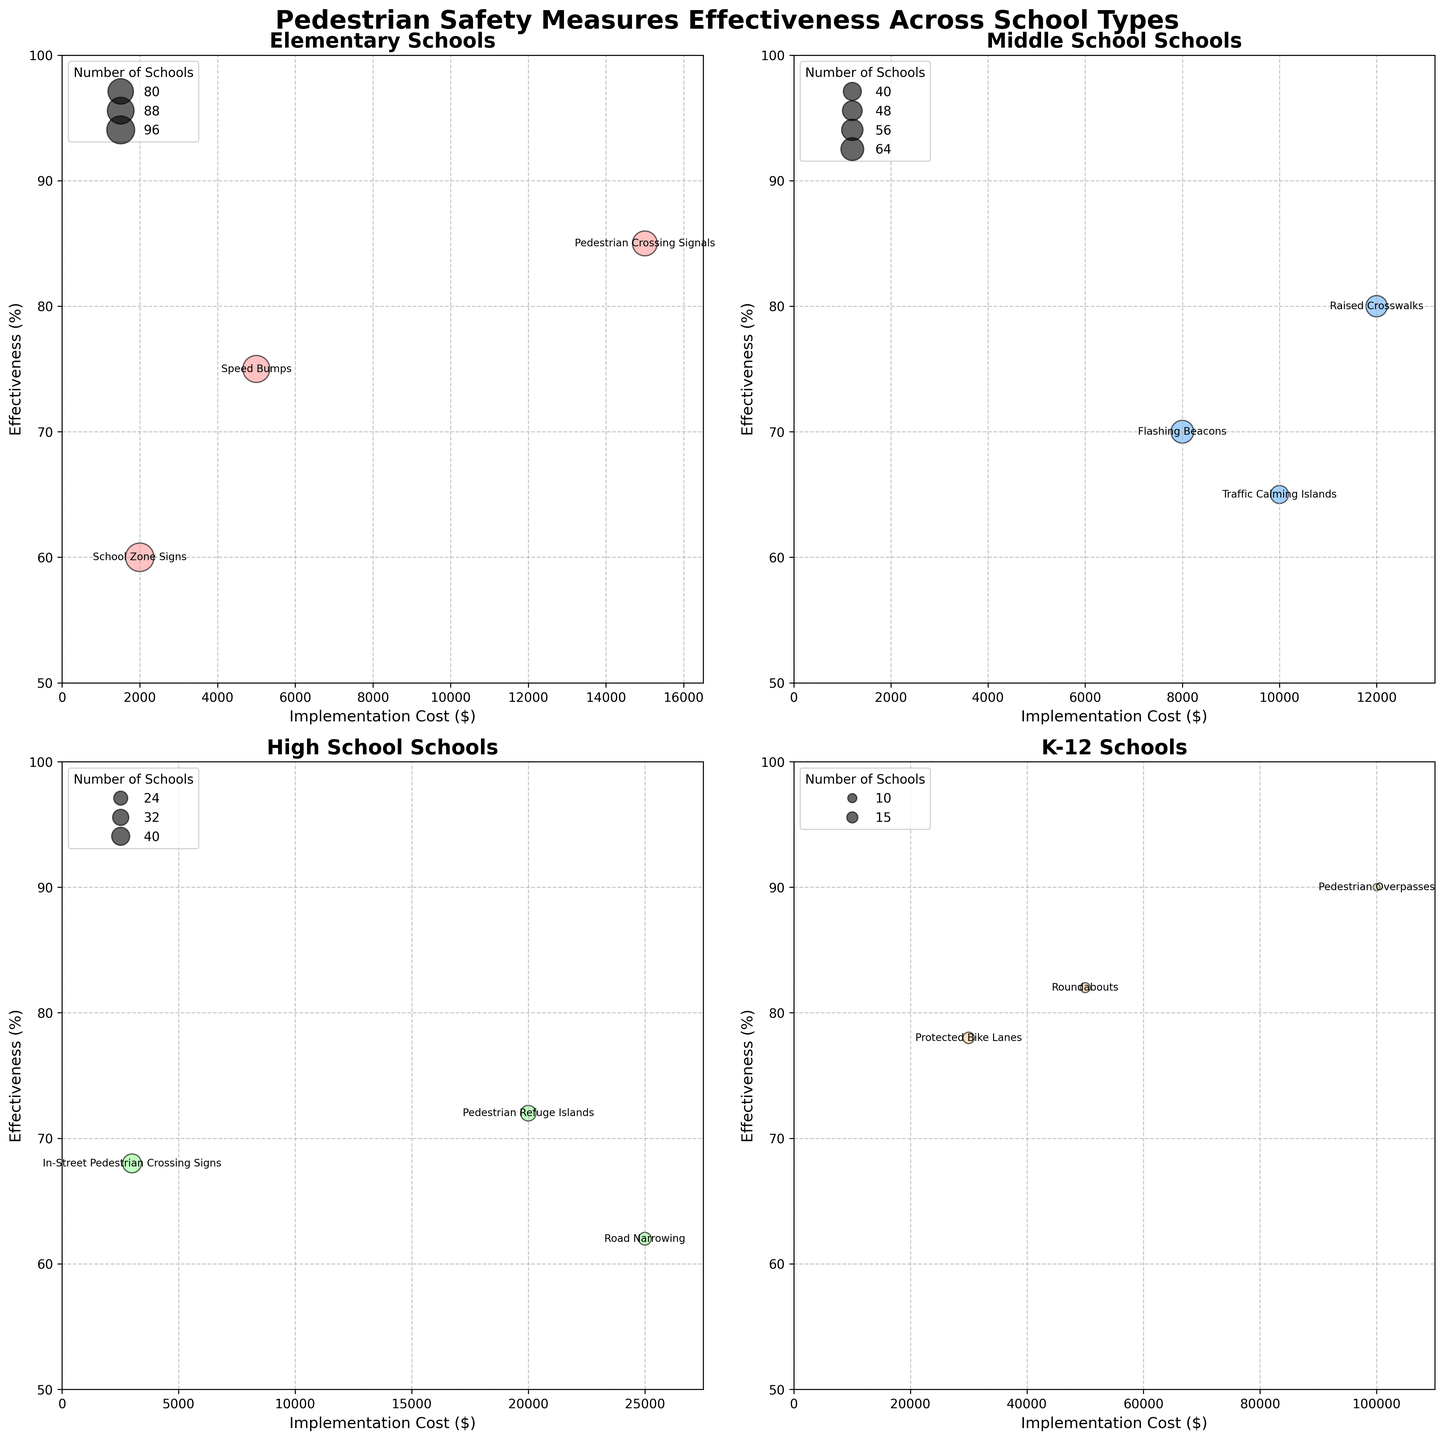What is the title of the plot? The title of the plot is displayed at the top center of the figure. It reads "Pedestrian Safety Measures Effectiveness Across School Types".
Answer: Pedestrian Safety Measures Effectiveness Across School Types How many safety measures are shown for Elementary schools? By observing the subplot dedicated to Elementary schools, we can count the number of annotated safety measures. There are three measures listed: Speed Bumps, Pedestrian Crossing Signals, and School Zone Signs.
Answer: 3 Which school type has a safety measure with the highest effectiveness percentage? By looking at the y-axis representing effectiveness in all subplots, we see that Pedestrian Overpasses in the K-12 subplot reaches the highest effectiveness at 90%. No other measures surpass this percentage.
Answer: K-12 What is the average implementation cost of the safety measures for Middle School? The safety measures for Middle School have implementation costs of $12,000, $8,000, and $10,000. Summing these gives $30,000, and dividing by the 3 measures gives an average cost of $10,000.
Answer: $10,000 Which safety measure for High School has the lowest effectiveness percentage and what is its implementation cost? In the subplot for High School, by comparing effectiveness percentages, Road Narrowing is identified with the lowest at 62%. Its implementation cost is $25,000.
Answer: Road Narrowing, $25,000 What is the total number of schools that have implemented Raised Crosswalks and Flashing Beacons in Middle Schools? Refer to the Middle School subplot and look at the annotations. Raised Crosswalks have 280 schools and Flashing Beacons have 320 schools. Summing these gives a total of 600 schools.
Answer: 600 Which safety measure across all school types has the largest bubble size, indicating the highest number of schools implemented? By examining the varying bubble sizes, School Zone Signs in Elementary schools have the largest bubble, indicating 500 schools implemented this measure, which is the highest number across all types.
Answer: School Zone Signs What is the difference in effectiveness between Traffic Calming Islands in Middle Schools and Pedestrian Refuge Islands in High Schools? Traffic Calming Islands in Middle Schools have an effectiveness of 65%, and Pedestrian Refuge Islands in High Schools have 72%. The difference is computed as 72% - 65%, which equals 7%.
Answer: 7% Which safety measure across all school types has the highest cost and what is its effectiveness percentage? The highest cost is associated with Pedestrian Overpasses in K-12 schools at $100,000. Its effectiveness percentage, indicated on the y-axis, is 90%.
Answer: Pedestrian Overpasses, 90% Are there more schools implementing Speed Bumps in Elementary or Traffic Calming Islands in Middle Schools? Comparing the subplot annotations, Speed Bumps in Elementary schools are implemented in 450 schools, while Traffic Calming Islands in Middle Schools are implemented in 200 schools. Elementary schools have more schools implementing Speed Bumps.
Answer: Elementary (Speed Bumps) 